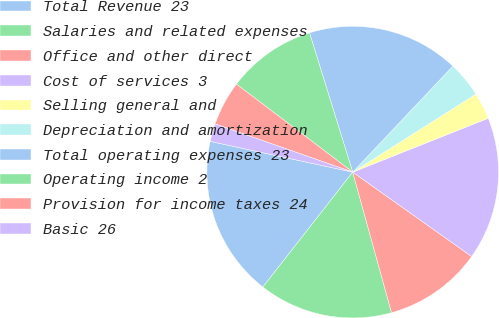Convert chart to OTSL. <chart><loc_0><loc_0><loc_500><loc_500><pie_chart><fcel>Total Revenue 23<fcel>Salaries and related expenses<fcel>Office and other direct<fcel>Cost of services 3<fcel>Selling general and<fcel>Depreciation and amortization<fcel>Total operating expenses 23<fcel>Operating income 2<fcel>Provision for income taxes 24<fcel>Basic 26<nl><fcel>17.82%<fcel>14.85%<fcel>10.89%<fcel>15.84%<fcel>2.97%<fcel>3.96%<fcel>16.83%<fcel>9.9%<fcel>4.95%<fcel>1.98%<nl></chart> 